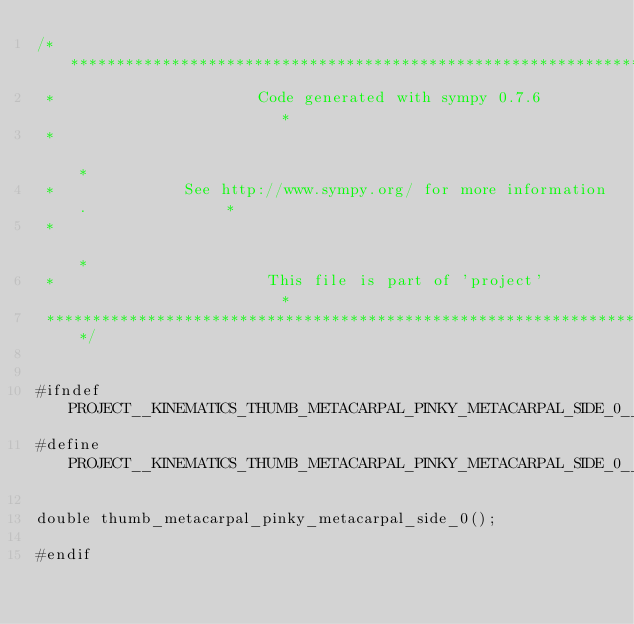<code> <loc_0><loc_0><loc_500><loc_500><_C_>/******************************************************************************
 *                      Code generated with sympy 0.7.6                       *
 *                                                                            *
 *              See http://www.sympy.org/ for more information.               *
 *                                                                            *
 *                       This file is part of 'project'                       *
 ******************************************************************************/


#ifndef PROJECT__KINEMATICS_THUMB_METACARPAL_PINKY_METACARPAL_SIDE_0__H
#define PROJECT__KINEMATICS_THUMB_METACARPAL_PINKY_METACARPAL_SIDE_0__H

double thumb_metacarpal_pinky_metacarpal_side_0();

#endif

</code> 